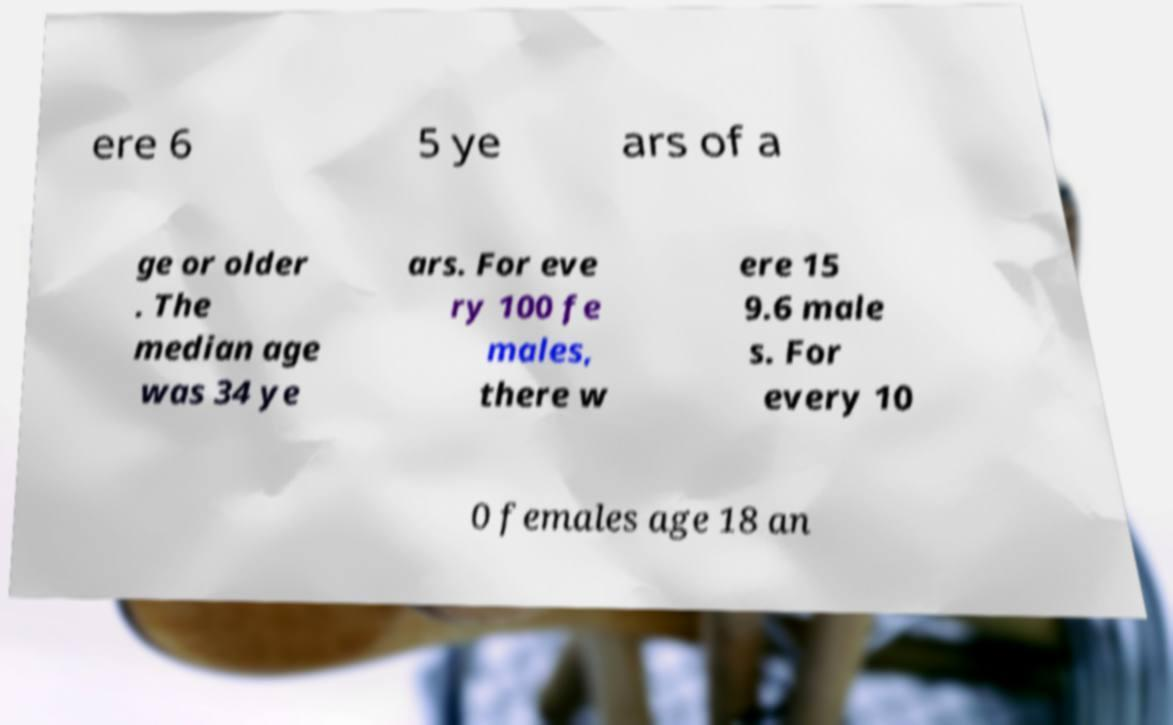Could you assist in decoding the text presented in this image and type it out clearly? ere 6 5 ye ars of a ge or older . The median age was 34 ye ars. For eve ry 100 fe males, there w ere 15 9.6 male s. For every 10 0 females age 18 an 